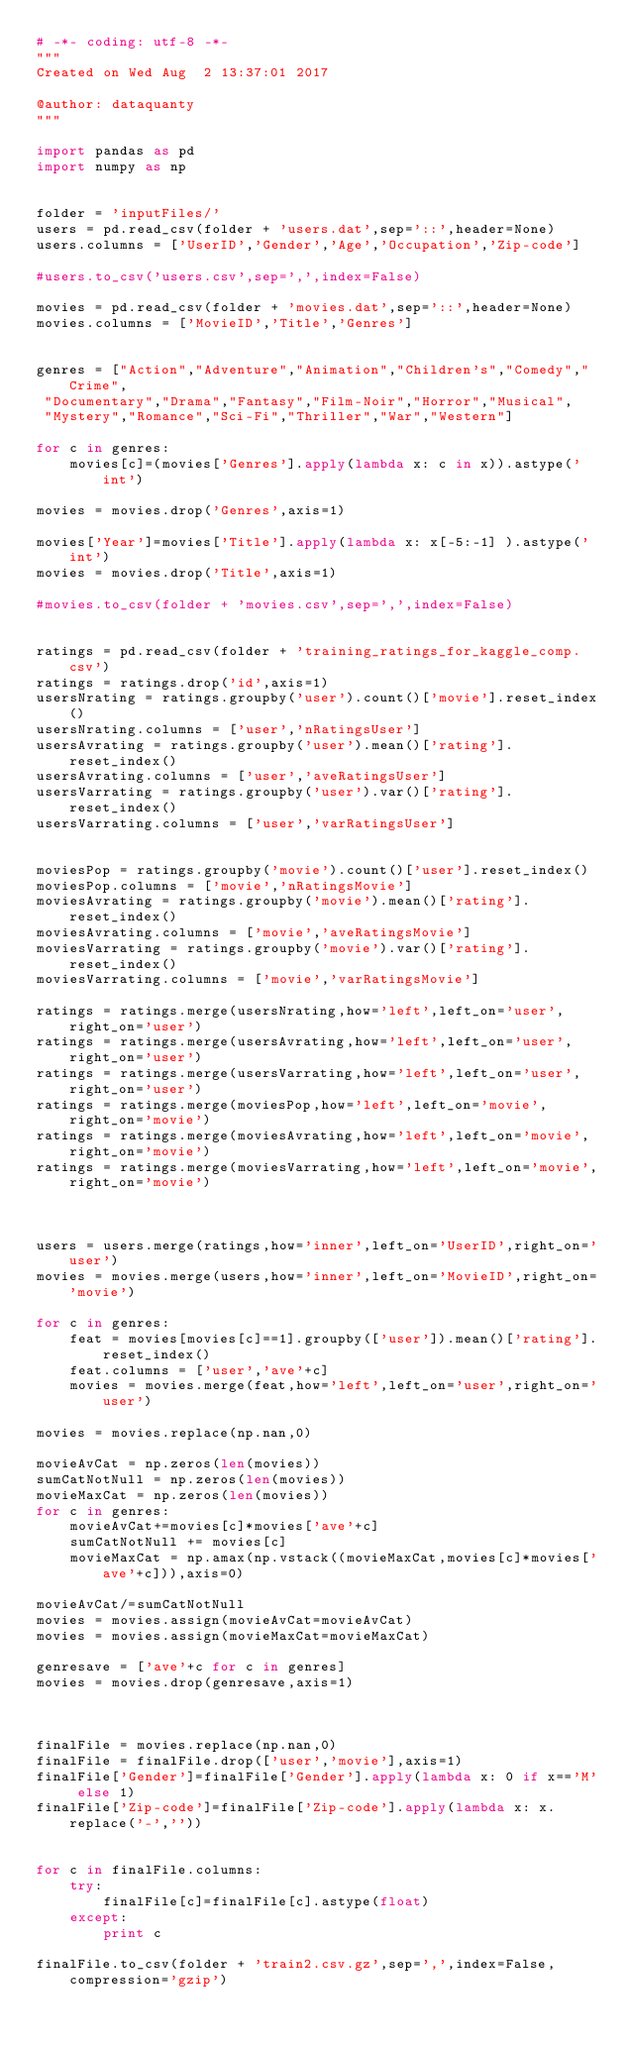<code> <loc_0><loc_0><loc_500><loc_500><_Python_># -*- coding: utf-8 -*-
"""
Created on Wed Aug  2 13:37:01 2017

@author: dataquanty
"""

import pandas as pd
import numpy as np


folder = 'inputFiles/'
users = pd.read_csv(folder + 'users.dat',sep='::',header=None)
users.columns = ['UserID','Gender','Age','Occupation','Zip-code']

#users.to_csv('users.csv',sep=',',index=False)

movies = pd.read_csv(folder + 'movies.dat',sep='::',header=None)
movies.columns = ['MovieID','Title','Genres']


genres = ["Action","Adventure","Animation","Children's","Comedy","Crime",
 "Documentary","Drama","Fantasy","Film-Noir","Horror","Musical",
 "Mystery","Romance","Sci-Fi","Thriller","War","Western"]

for c in genres:
    movies[c]=(movies['Genres'].apply(lambda x: c in x)).astype('int')
    
movies = movies.drop('Genres',axis=1)

movies['Year']=movies['Title'].apply(lambda x: x[-5:-1] ).astype('int')
movies = movies.drop('Title',axis=1)

#movies.to_csv(folder + 'movies.csv',sep=',',index=False)


ratings = pd.read_csv(folder + 'training_ratings_for_kaggle_comp.csv')
ratings = ratings.drop('id',axis=1)
usersNrating = ratings.groupby('user').count()['movie'].reset_index()
usersNrating.columns = ['user','nRatingsUser']
usersAvrating = ratings.groupby('user').mean()['rating'].reset_index()
usersAvrating.columns = ['user','aveRatingsUser']
usersVarrating = ratings.groupby('user').var()['rating'].reset_index()
usersVarrating.columns = ['user','varRatingsUser']


moviesPop = ratings.groupby('movie').count()['user'].reset_index()
moviesPop.columns = ['movie','nRatingsMovie']
moviesAvrating = ratings.groupby('movie').mean()['rating'].reset_index()
moviesAvrating.columns = ['movie','aveRatingsMovie']
moviesVarrating = ratings.groupby('movie').var()['rating'].reset_index()
moviesVarrating.columns = ['movie','varRatingsMovie']

ratings = ratings.merge(usersNrating,how='left',left_on='user',right_on='user')
ratings = ratings.merge(usersAvrating,how='left',left_on='user',right_on='user')
ratings = ratings.merge(usersVarrating,how='left',left_on='user',right_on='user')
ratings = ratings.merge(moviesPop,how='left',left_on='movie',right_on='movie')
ratings = ratings.merge(moviesAvrating,how='left',left_on='movie',right_on='movie')
ratings = ratings.merge(moviesVarrating,how='left',left_on='movie',right_on='movie')



users = users.merge(ratings,how='inner',left_on='UserID',right_on='user') 
movies = movies.merge(users,how='inner',left_on='MovieID',right_on='movie') 

for c in genres:
    feat = movies[movies[c]==1].groupby(['user']).mean()['rating'].reset_index()
    feat.columns = ['user','ave'+c]
    movies = movies.merge(feat,how='left',left_on='user',right_on='user')

movies = movies.replace(np.nan,0)

movieAvCat = np.zeros(len(movies))
sumCatNotNull = np.zeros(len(movies))
movieMaxCat = np.zeros(len(movies))
for c in genres:
    movieAvCat+=movies[c]*movies['ave'+c]
    sumCatNotNull += movies[c]
    movieMaxCat = np.amax(np.vstack((movieMaxCat,movies[c]*movies['ave'+c])),axis=0)
    
movieAvCat/=sumCatNotNull
movies = movies.assign(movieAvCat=movieAvCat)
movies = movies.assign(movieMaxCat=movieMaxCat)

genresave = ['ave'+c for c in genres]
movies = movies.drop(genresave,axis=1)



finalFile = movies.replace(np.nan,0)
finalFile = finalFile.drop(['user','movie'],axis=1)
finalFile['Gender']=finalFile['Gender'].apply(lambda x: 0 if x=='M' else 1)
finalFile['Zip-code']=finalFile['Zip-code'].apply(lambda x: x.replace('-',''))


for c in finalFile.columns:
    try:
        finalFile[c]=finalFile[c].astype(float)
    except:
        print c
        
finalFile.to_csv(folder + 'train2.csv.gz',sep=',',index=False,compression='gzip')

</code> 